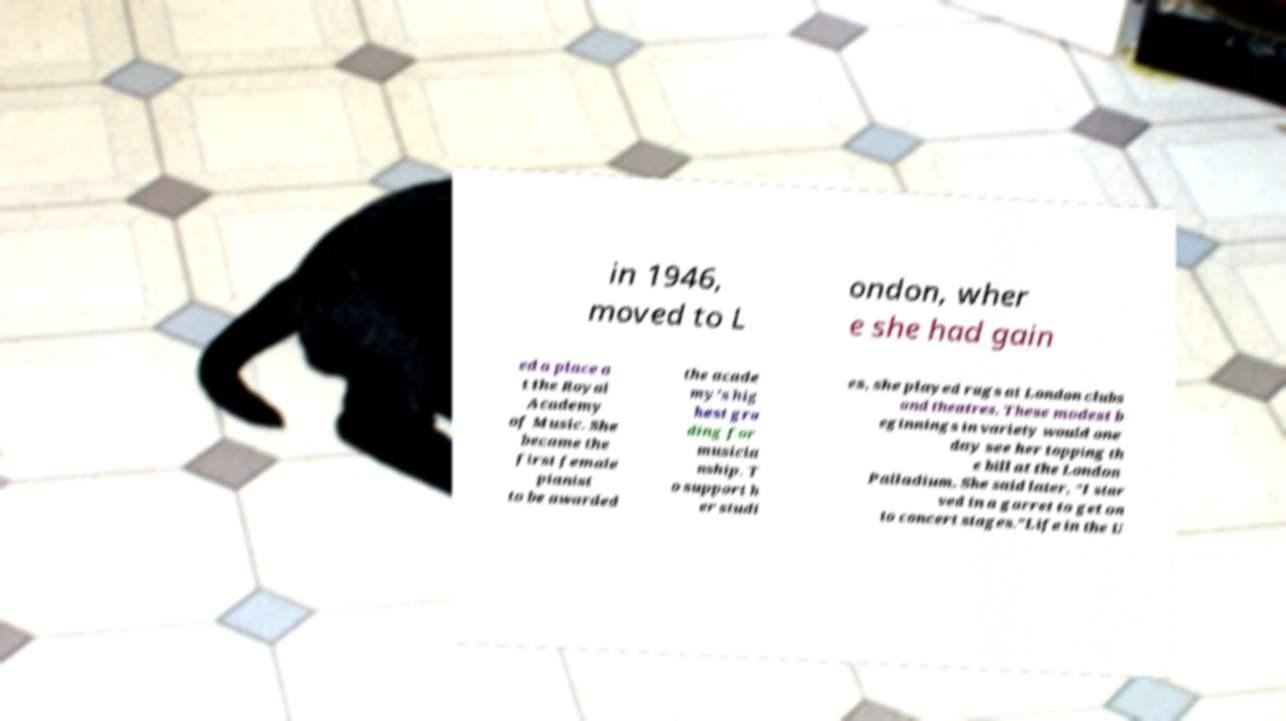Please read and relay the text visible in this image. What does it say? in 1946, moved to L ondon, wher e she had gain ed a place a t the Royal Academy of Music. She became the first female pianist to be awarded the acade my's hig hest gra ding for musicia nship. T o support h er studi es, she played rags at London clubs and theatres. These modest b eginnings in variety would one day see her topping th e bill at the London Palladium. She said later, "I star ved in a garret to get on to concert stages."Life in the U 